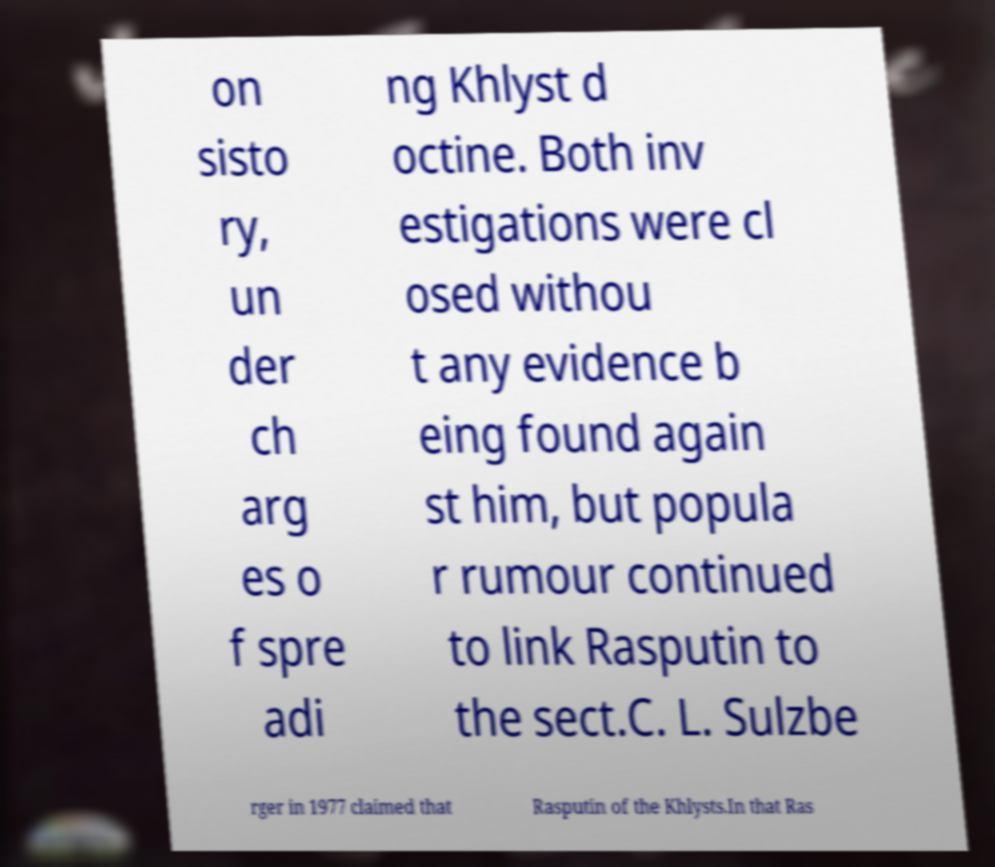Please identify and transcribe the text found in this image. on sisto ry, un der ch arg es o f spre adi ng Khlyst d octine. Both inv estigations were cl osed withou t any evidence b eing found again st him, but popula r rumour continued to link Rasputin to the sect.C. L. Sulzbe rger in 1977 claimed that Rasputin of the Khlysts.In that Ras 